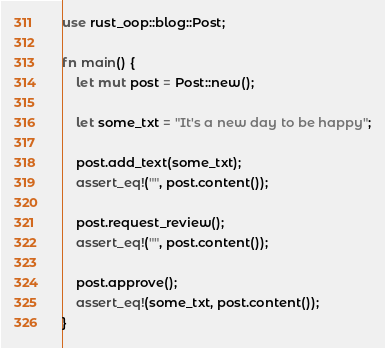Convert code to text. <code><loc_0><loc_0><loc_500><loc_500><_Rust_>use rust_oop::blog::Post;

fn main() {
    let mut post = Post::new();

    let some_txt = "It's a new day to be happy";

    post.add_text(some_txt);
    assert_eq!("", post.content());

    post.request_review();
    assert_eq!("", post.content());

    post.approve();
    assert_eq!(some_txt, post.content());
}
</code> 